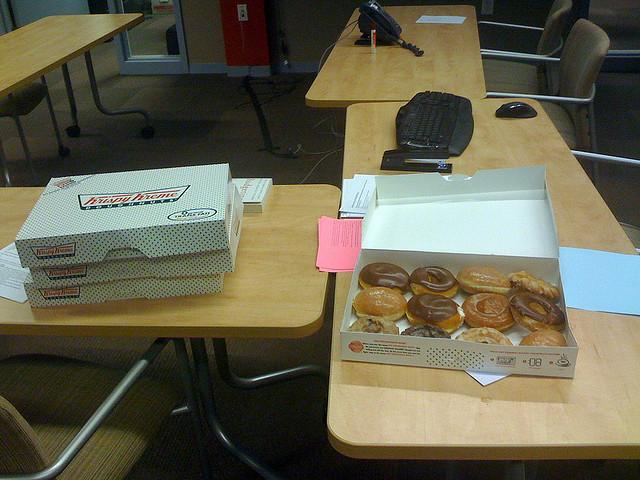Who is a competitor of this company?

Choices:
A) dunkin donuts
B) nathans
C) office max
D) home depot dunkin donuts 